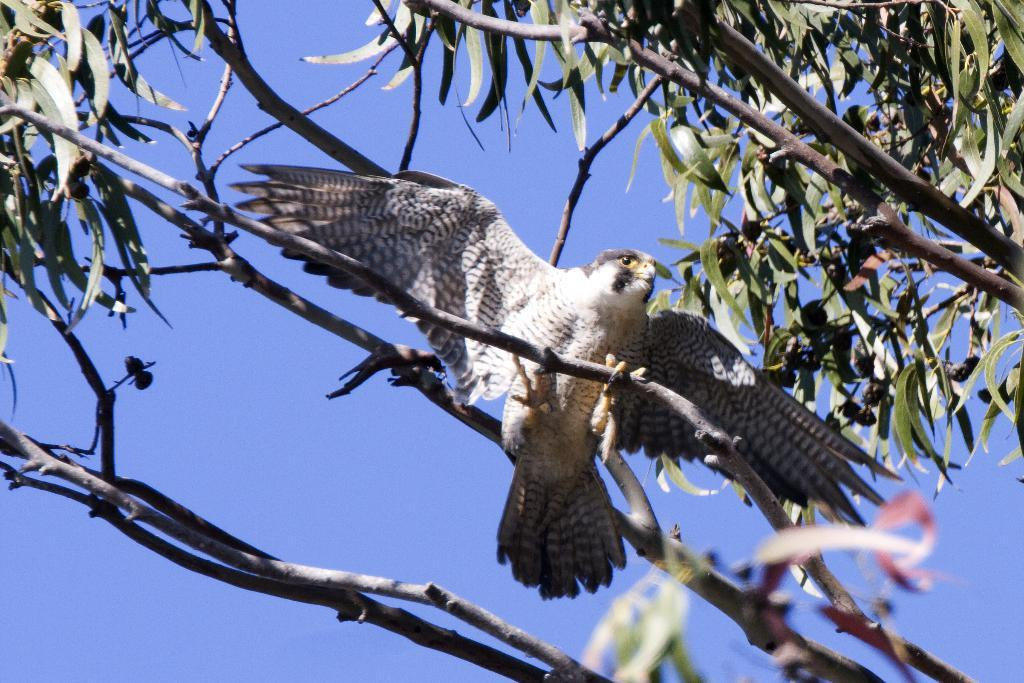What type of animal is in the image? There is a bird in the image. Where is the bird located? The bird is on a branch of a tree. What can be seen in the background of the image? The sky is visible in the background of the image. What type of field can be seen in the image? There is no field present in the image; it features a bird on a tree branch with the sky visible in the background. 